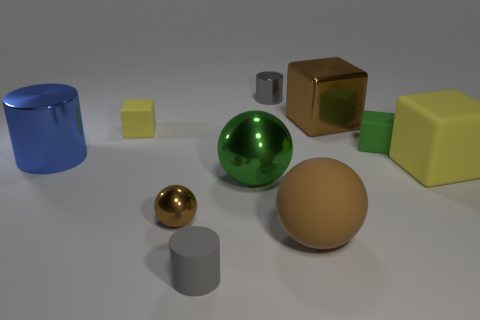Subtract all cylinders. How many objects are left? 7 Add 9 large brown rubber balls. How many large brown rubber balls exist? 10 Subtract 2 gray cylinders. How many objects are left? 8 Subtract all small cubes. Subtract all green objects. How many objects are left? 6 Add 4 small green rubber cubes. How many small green rubber cubes are left? 5 